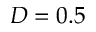<formula> <loc_0><loc_0><loc_500><loc_500>D = 0 . 5</formula> 